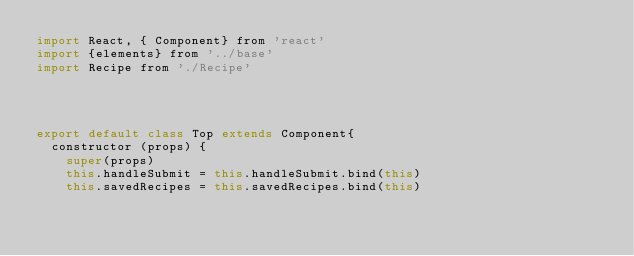Convert code to text. <code><loc_0><loc_0><loc_500><loc_500><_JavaScript_>import React, { Component} from 'react'
import {elements} from '../base'
import Recipe from './Recipe'




export default class Top extends Component{
  constructor (props) {
    super(props)
    this.handleSubmit = this.handleSubmit.bind(this)
    this.savedRecipes = this.savedRecipes.bind(this)</code> 